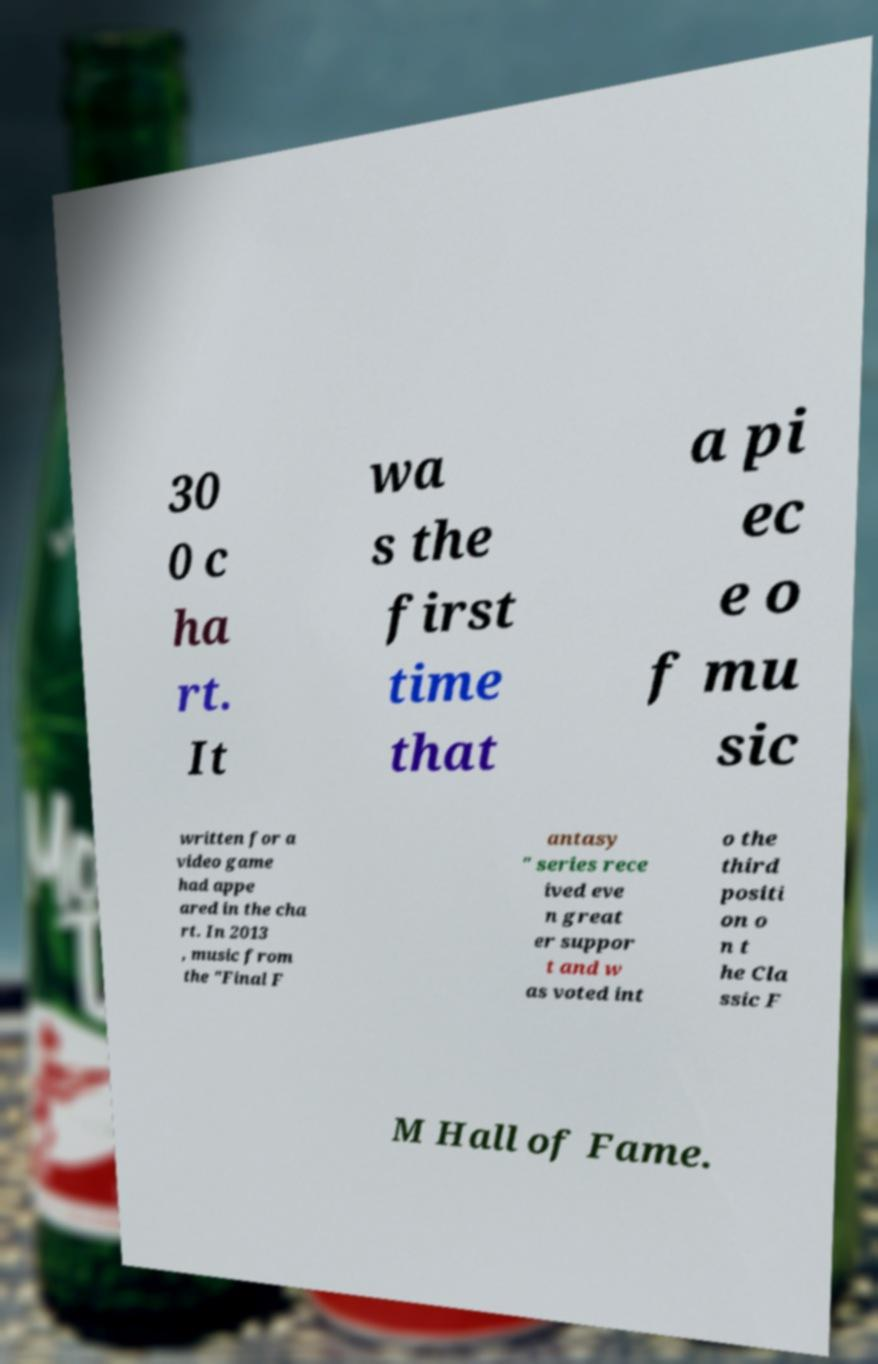For documentation purposes, I need the text within this image transcribed. Could you provide that? 30 0 c ha rt. It wa s the first time that a pi ec e o f mu sic written for a video game had appe ared in the cha rt. In 2013 , music from the "Final F antasy " series rece ived eve n great er suppor t and w as voted int o the third positi on o n t he Cla ssic F M Hall of Fame. 